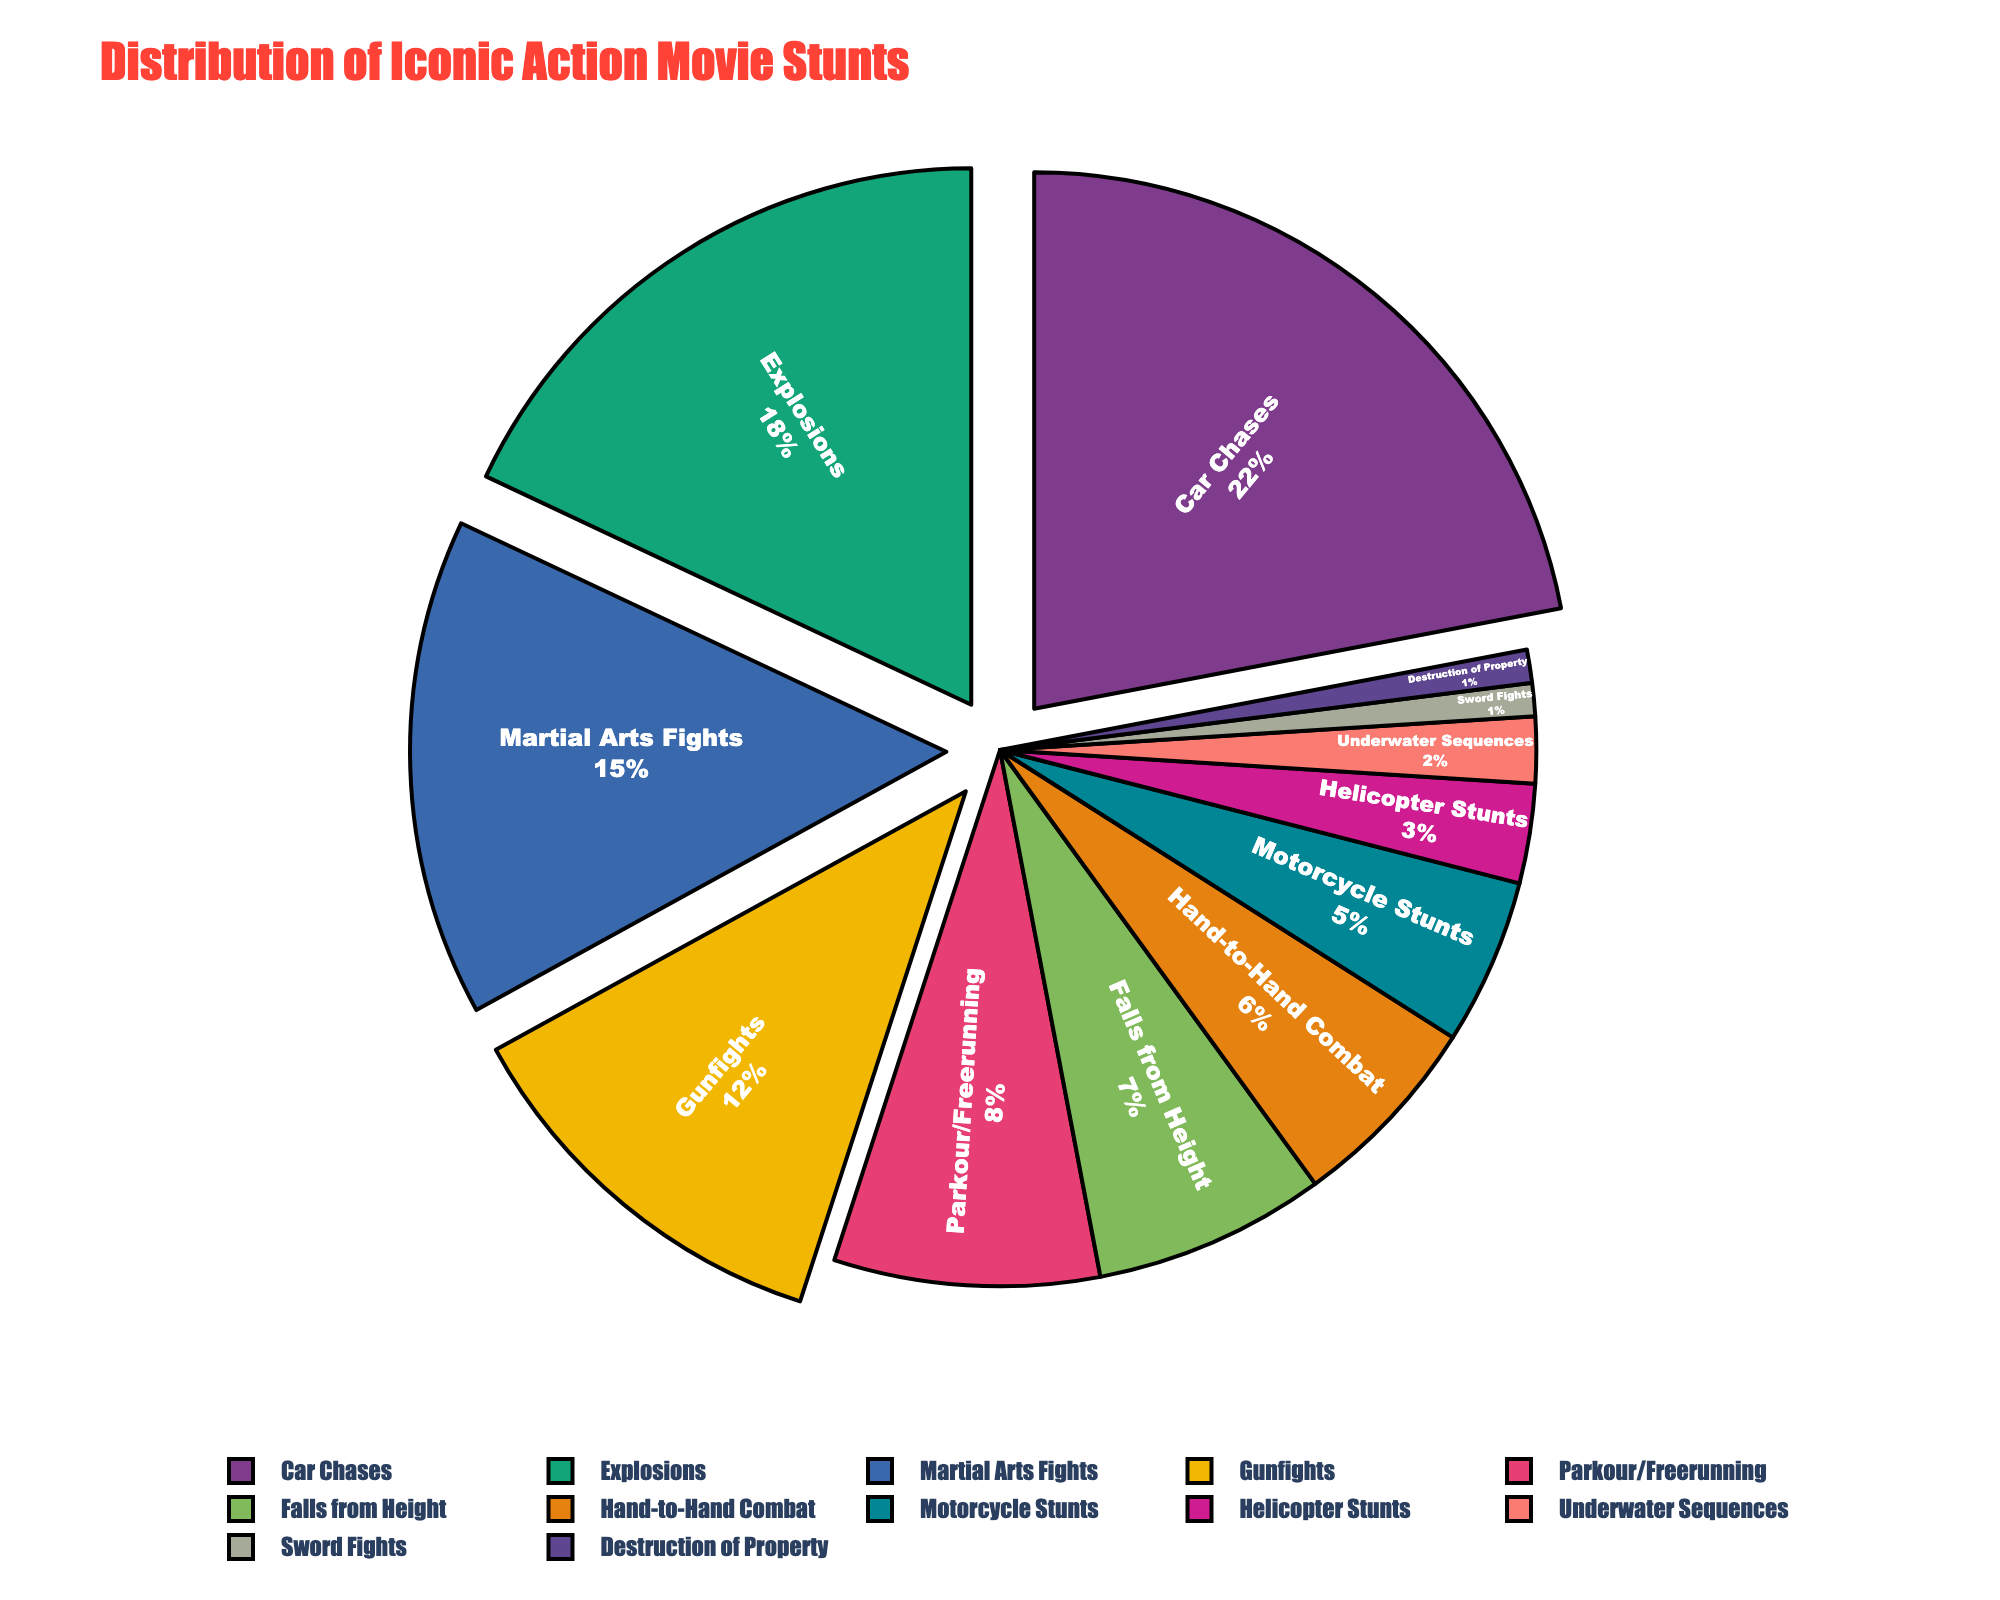Which stunt type makes up the largest percentage of iconic action movie stunts? The stunt type with the largest slice in the pie chart is the one with the highest percentage value. Looking at the chart, "Car Chases" occupy the largest slice.
Answer: Car Chases Which two stunt types combined make up 30% of the iconic action movie stunts? To find a combination that sums to 30%, we look for pairs of percentages that add up to 30. "Explosions" (18%) + "Parkour/Freerunning" (8%) = 26% and "Martial Arts Fights" (15%) + "Gunfights" (12%) = 27%, but "Car Chases" (22%) + "Falls from Height" (7%) = 29%. So, the exact combination needed is not present.
Answer: None Is the percentage of "Explosions" greater than the percentage of "Martial Arts Fights"? Compare the percentages directly from the pie chart. "Explosions" is 18% and "Martial Arts Fights" is 15%. Therefore, 18% is greater than 15%.
Answer: Yes How many stunt types have a percentage lower than "Hand-to-Hand Combat"? Identify the percentage of "Hand-to-Hand Combat" which is 6% and count all stunt types with lower percentages. They are "Motorcycle Stunts" (5%), "Helicopter Stunts" (3%), "Underwater Sequences" (2%), "Sword Fights" (1%), and "Destruction of Property" (1%). There are 5.
Answer: 5 What is the total percentage of stunts that involve fighting? Add the percentages of "Martial Arts Fights" (15%), "Hand-to-Hand Combat" (6%), "Gunfights" (12%), and "Sword Fights" (1%). So, 15% + 6% + 12% + 1% = 34%.
Answer: 34% Which stunt type has the smallest slice in the pie chart? Identify the smallest slice visually, which corresponds to the smallest percentage. Both "Sword Fights" and "Destruction of Property" share the smallest slice at 1%.
Answer: Sword Fights, Destruction of Property Are the combined percentages of "Parkour/Freerunning" and "Falls from Height" less than "Car Chases"? Add the percentages of "Parkour/Freerunning" (8%) and "Falls from Height" (7%) and compare to "Car Chases" (22%). 8% + 7% = 15%, which is less than 22%.
Answer: Yes What is the difference in percentage between "Car Chases" and "Explosions"? Subtract the percentage of "Explosions" from "Car Chases". 22% - 18% = 4%.
Answer: 4% If you replaced "Martial Arts Fights" with an equal percentage "Destruction of Property", what would be the percentage for "Destruction of Property"? "Martial Arts Fights" are 15%, and adding this to the original "Destruction of Property" (which is 1%), the new percentage would be 15% + 1% = 16%.
Answer: 16% What is the visual distinction used to highlight slices above 10%? The pie chart uses a "pull" effect to visually distinguish slices above 10%, appearing as if they are slightly separated from the rest of the pie chart.
Answer: Pull effect 